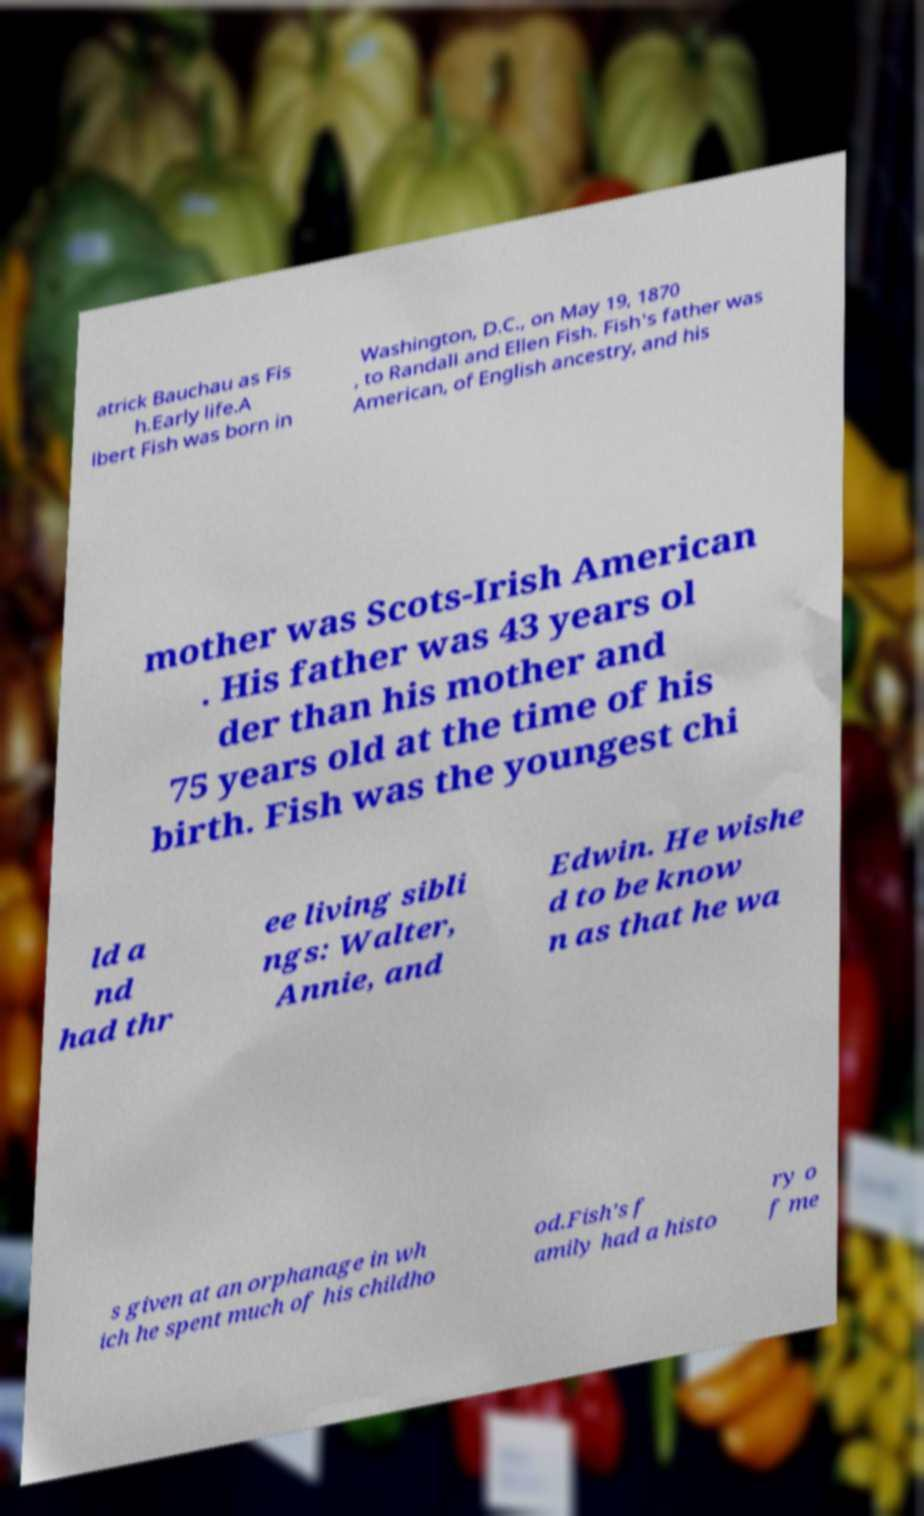Please read and relay the text visible in this image. What does it say? atrick Bauchau as Fis h.Early life.A lbert Fish was born in Washington, D.C., on May 19, 1870 , to Randall and Ellen Fish. Fish's father was American, of English ancestry, and his mother was Scots-Irish American . His father was 43 years ol der than his mother and 75 years old at the time of his birth. Fish was the youngest chi ld a nd had thr ee living sibli ngs: Walter, Annie, and Edwin. He wishe d to be know n as that he wa s given at an orphanage in wh ich he spent much of his childho od.Fish's f amily had a histo ry o f me 